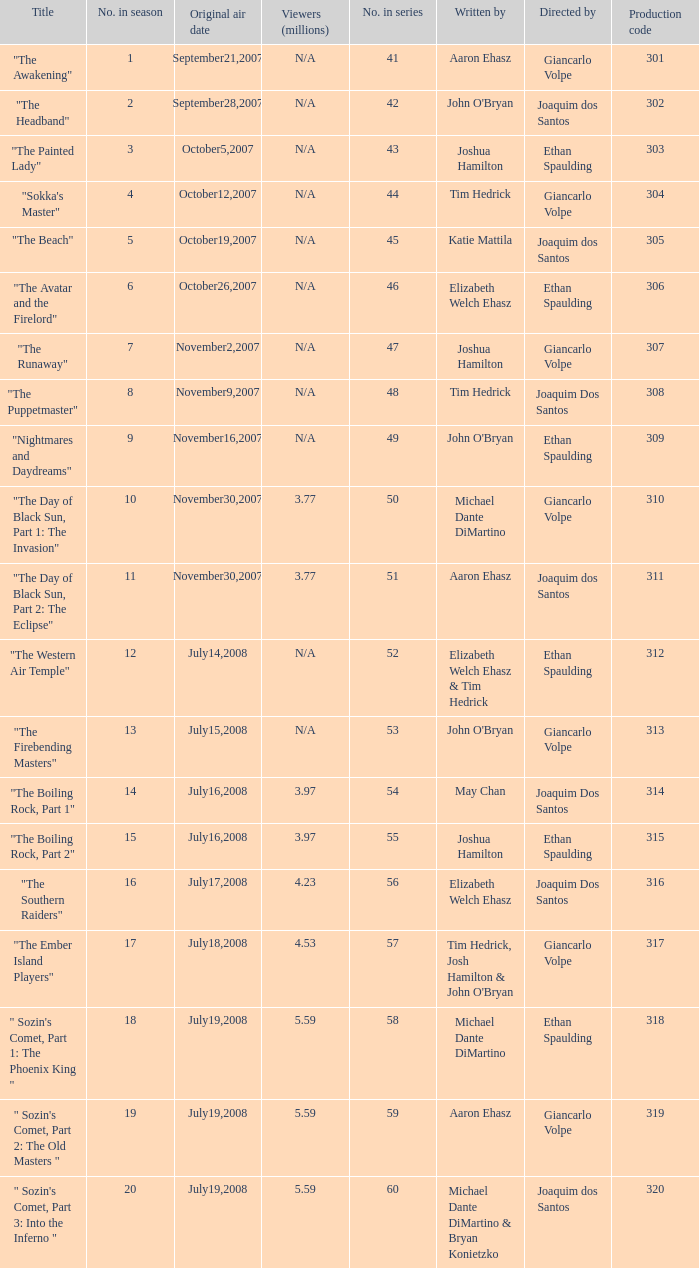What is the original air date for the episode with a production code of 318? July19,2008. 